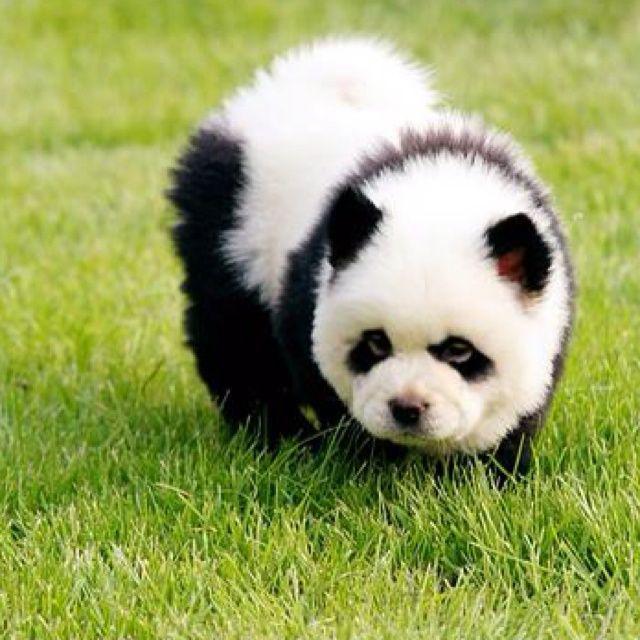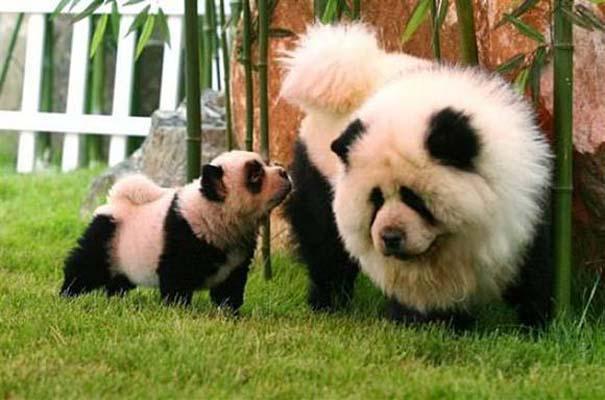The first image is the image on the left, the second image is the image on the right. Considering the images on both sides, is "There's at least three dogs in the right image." valid? Answer yes or no. No. The first image is the image on the left, the second image is the image on the right. Given the left and right images, does the statement "An image shows three panda-look chows, with one reclining and two sitting up." hold true? Answer yes or no. No. 